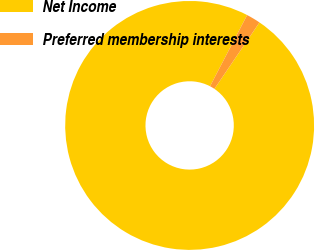Convert chart. <chart><loc_0><loc_0><loc_500><loc_500><pie_chart><fcel>Net Income<fcel>Preferred membership interests<nl><fcel>98.16%<fcel>1.84%<nl></chart> 